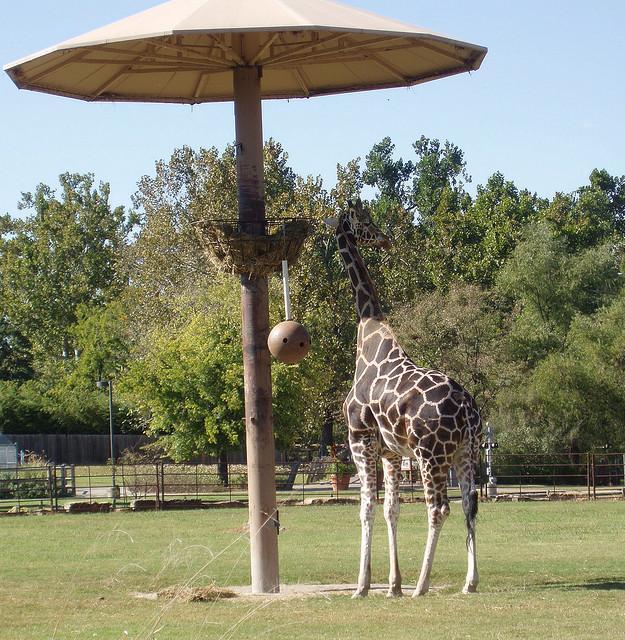How many giraffes are seen?
Give a very brief answer. 1. 